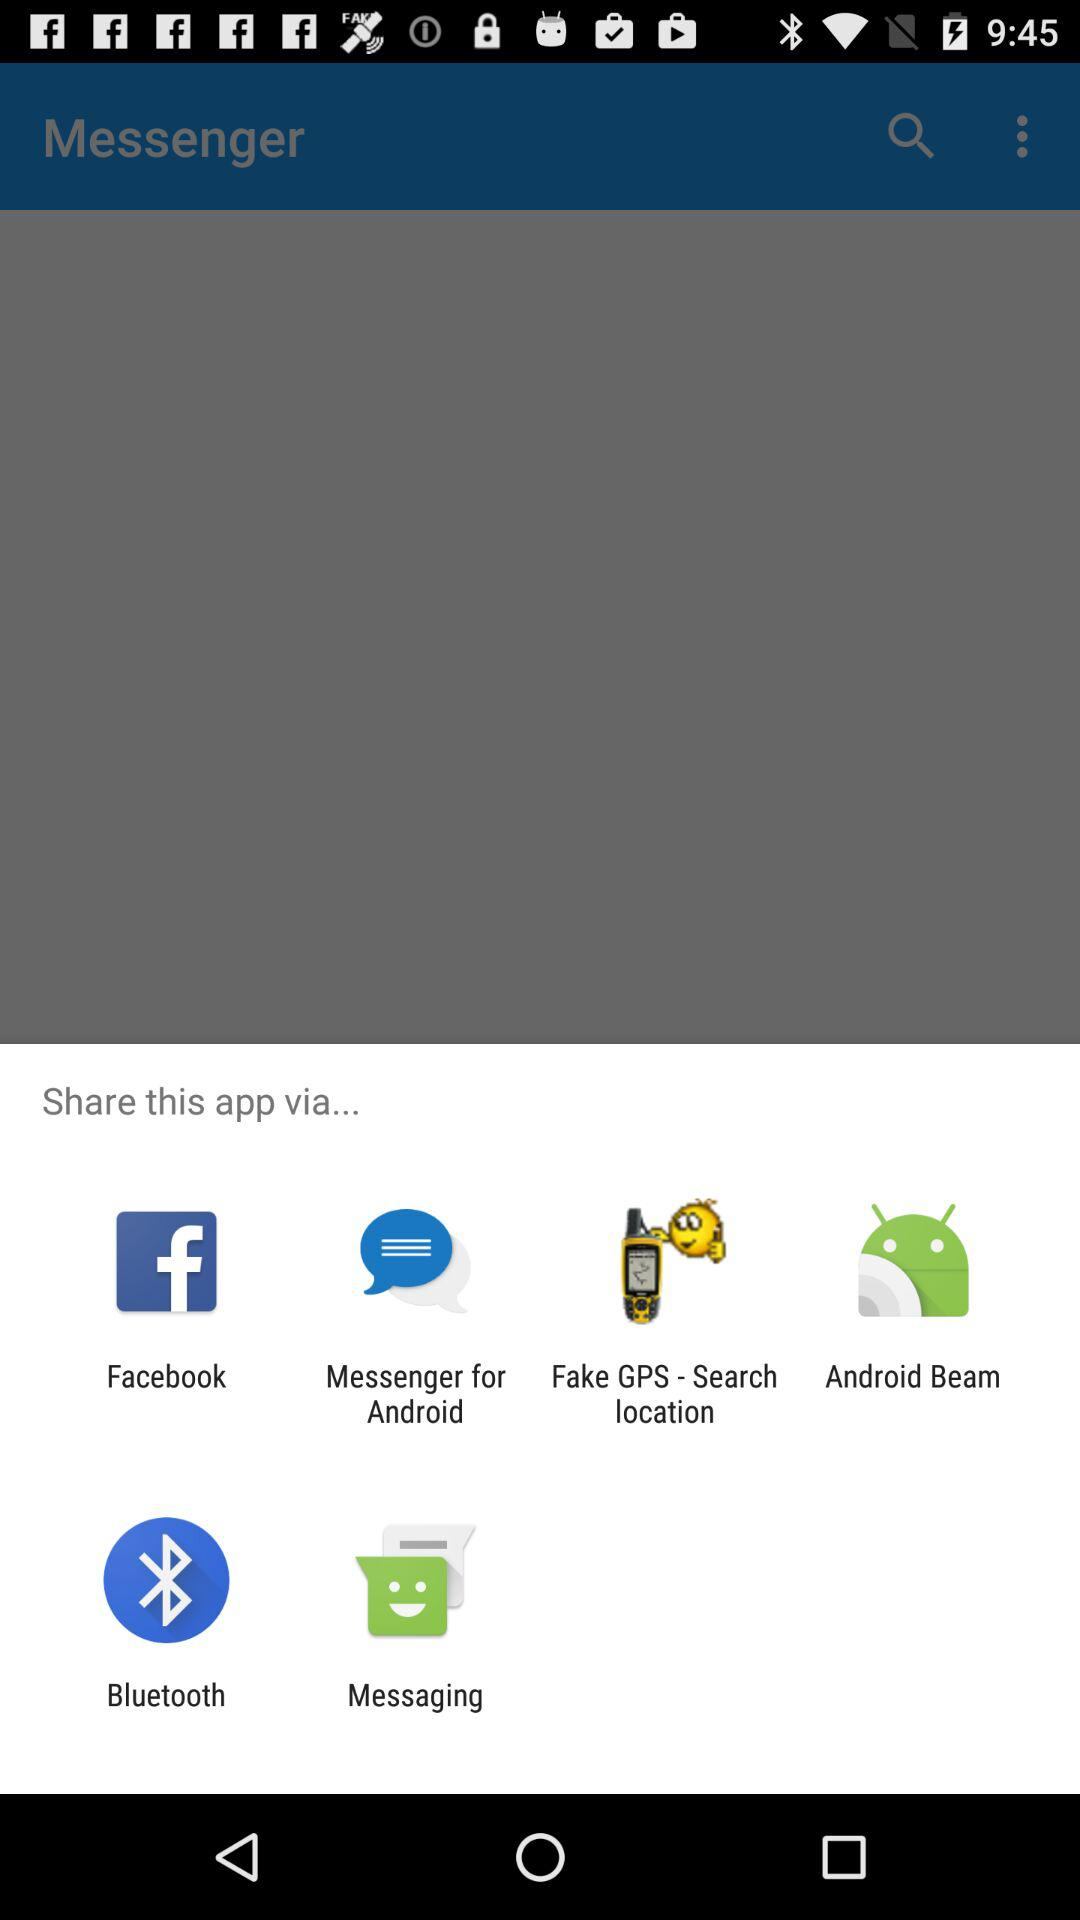Which are the different sharing options? The different sharing options are "Facebook", "Messenger for Android", "Fake GPS - Search location", "Android Beam", "Bluetooth" and "Messaging". 